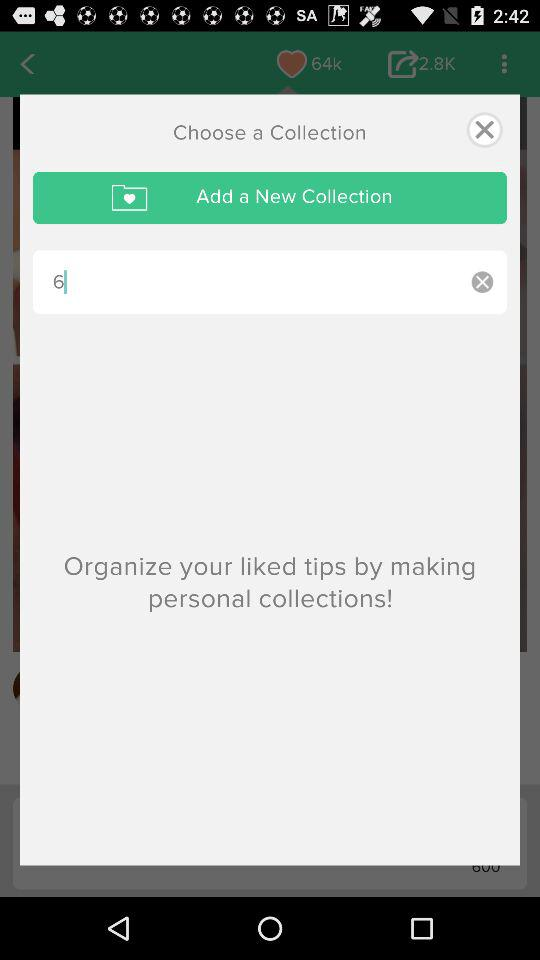What's the number of collections?
When the provided information is insufficient, respond with <no answer>. <no answer> 